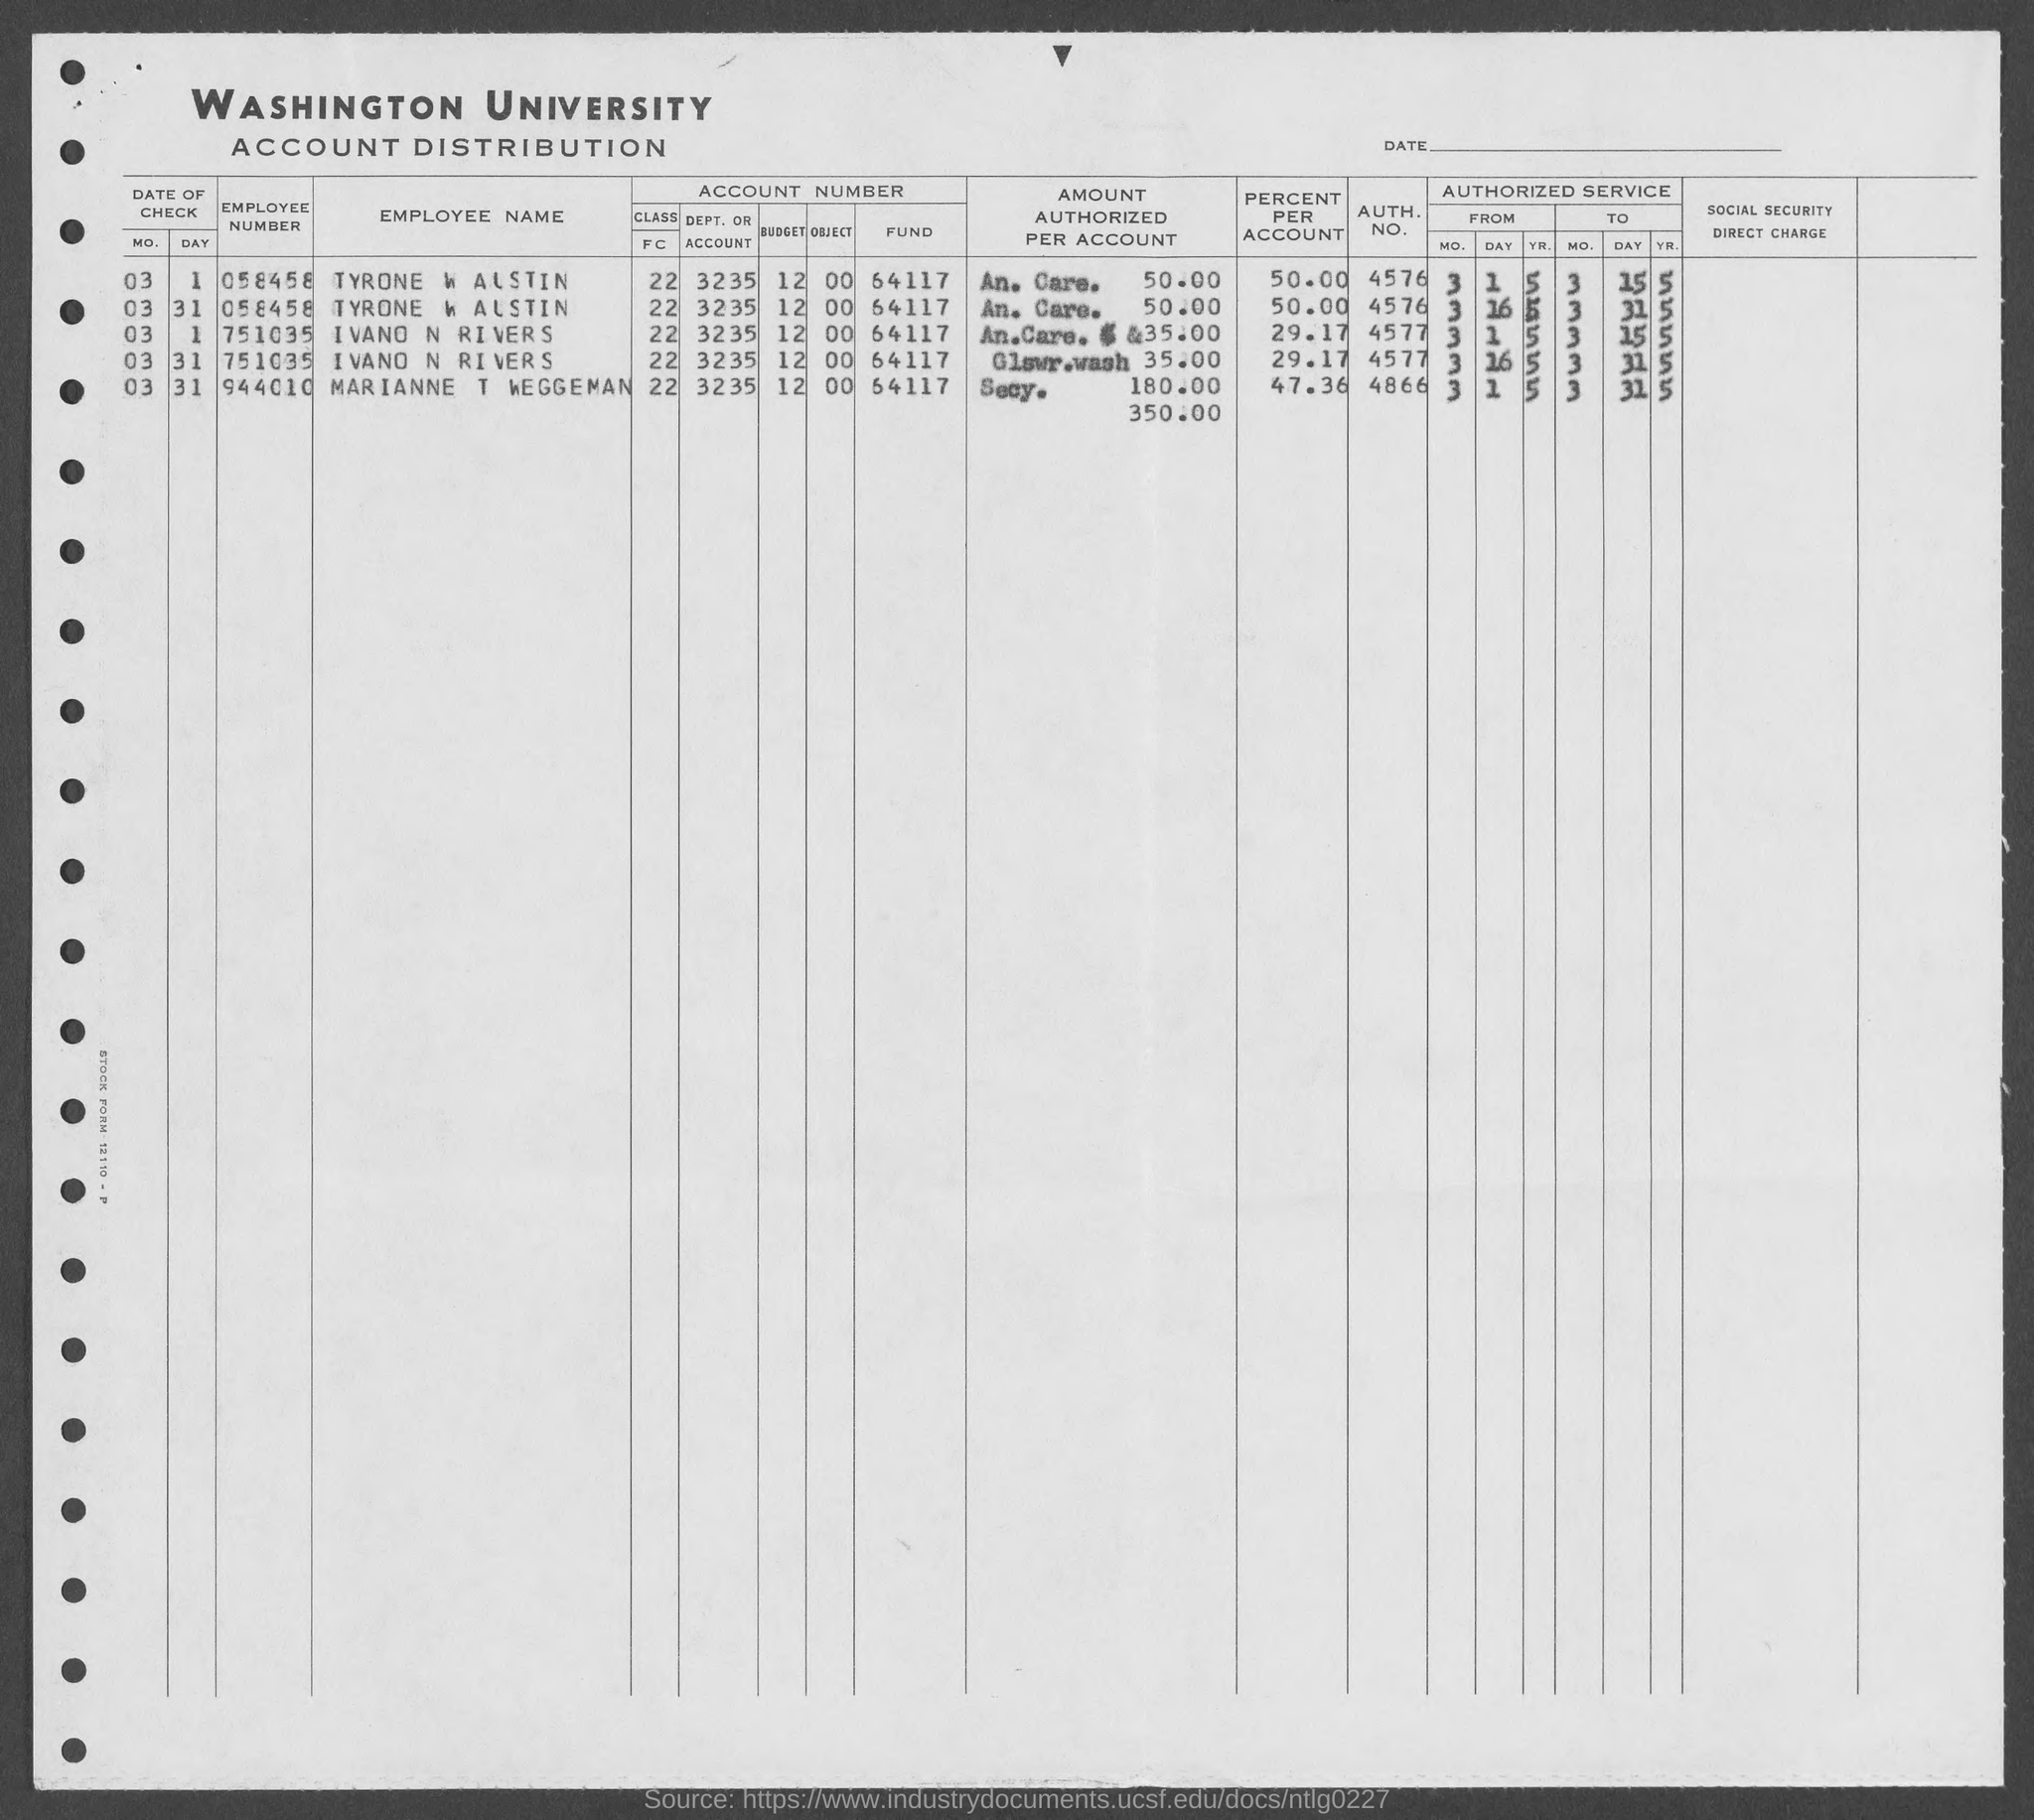Outline some significant characteristics in this image. The employee number of Tyrone W. Austin is 058458. Marianne T Weggeman's employee number is 944010. The distribution of university accounts is provided by Washington University. 